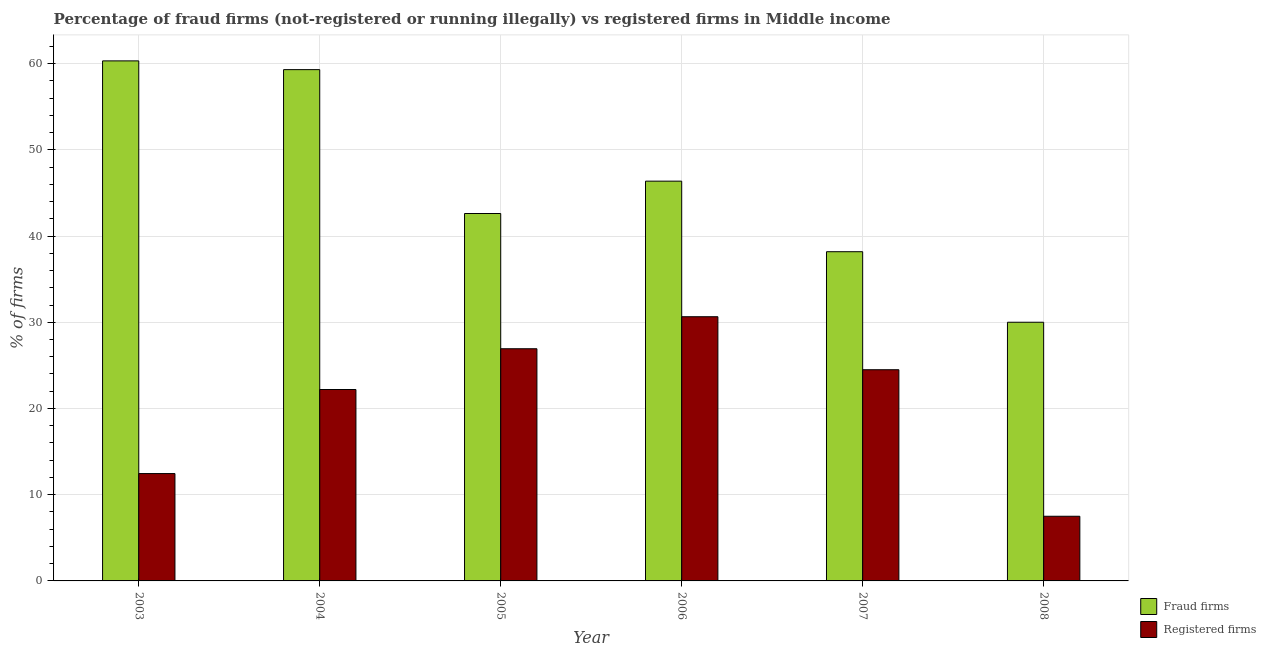How many different coloured bars are there?
Keep it short and to the point. 2. How many bars are there on the 1st tick from the right?
Give a very brief answer. 2. In how many cases, is the number of bars for a given year not equal to the number of legend labels?
Offer a very short reply. 0. What is the percentage of registered firms in 2003?
Ensure brevity in your answer.  12.45. Across all years, what is the maximum percentage of registered firms?
Keep it short and to the point. 30.64. In which year was the percentage of registered firms maximum?
Provide a succinct answer. 2006. What is the total percentage of registered firms in the graph?
Offer a terse response. 124.21. What is the difference between the percentage of fraud firms in 2004 and that in 2007?
Your response must be concise. 21.12. What is the difference between the percentage of fraud firms in 2008 and the percentage of registered firms in 2004?
Make the answer very short. -29.3. What is the average percentage of fraud firms per year?
Ensure brevity in your answer.  46.13. What is the ratio of the percentage of fraud firms in 2004 to that in 2005?
Your answer should be very brief. 1.39. Is the percentage of fraud firms in 2003 less than that in 2005?
Ensure brevity in your answer.  No. Is the difference between the percentage of fraud firms in 2006 and 2008 greater than the difference between the percentage of registered firms in 2006 and 2008?
Your answer should be compact. No. What is the difference between the highest and the second highest percentage of registered firms?
Your answer should be very brief. 3.71. What is the difference between the highest and the lowest percentage of fraud firms?
Your answer should be compact. 30.31. Is the sum of the percentage of registered firms in 2003 and 2008 greater than the maximum percentage of fraud firms across all years?
Keep it short and to the point. No. What does the 2nd bar from the left in 2008 represents?
Provide a succinct answer. Registered firms. What does the 1st bar from the right in 2005 represents?
Make the answer very short. Registered firms. How many years are there in the graph?
Keep it short and to the point. 6. What is the difference between two consecutive major ticks on the Y-axis?
Make the answer very short. 10. Are the values on the major ticks of Y-axis written in scientific E-notation?
Keep it short and to the point. No. Does the graph contain any zero values?
Your answer should be very brief. No. Where does the legend appear in the graph?
Your answer should be very brief. Bottom right. How are the legend labels stacked?
Offer a terse response. Vertical. What is the title of the graph?
Provide a short and direct response. Percentage of fraud firms (not-registered or running illegally) vs registered firms in Middle income. Does "US$" appear as one of the legend labels in the graph?
Make the answer very short. No. What is the label or title of the X-axis?
Provide a succinct answer. Year. What is the label or title of the Y-axis?
Offer a very short reply. % of firms. What is the % of firms in Fraud firms in 2003?
Offer a very short reply. 60.31. What is the % of firms of Registered firms in 2003?
Give a very brief answer. 12.45. What is the % of firms in Fraud firms in 2004?
Offer a very short reply. 59.3. What is the % of firms in Fraud firms in 2005?
Keep it short and to the point. 42.61. What is the % of firms in Registered firms in 2005?
Keep it short and to the point. 26.93. What is the % of firms in Fraud firms in 2006?
Your answer should be compact. 46.36. What is the % of firms in Registered firms in 2006?
Offer a terse response. 30.64. What is the % of firms in Fraud firms in 2007?
Your answer should be very brief. 38.18. What is the % of firms of Registered firms in 2007?
Your response must be concise. 24.49. What is the % of firms in Fraud firms in 2008?
Provide a short and direct response. 30. What is the % of firms of Registered firms in 2008?
Offer a very short reply. 7.5. Across all years, what is the maximum % of firms of Fraud firms?
Keep it short and to the point. 60.31. Across all years, what is the maximum % of firms in Registered firms?
Your answer should be compact. 30.64. Across all years, what is the minimum % of firms in Fraud firms?
Your answer should be very brief. 30. Across all years, what is the minimum % of firms of Registered firms?
Offer a terse response. 7.5. What is the total % of firms in Fraud firms in the graph?
Ensure brevity in your answer.  276.76. What is the total % of firms in Registered firms in the graph?
Your response must be concise. 124.21. What is the difference between the % of firms in Fraud firms in 2003 and that in 2004?
Make the answer very short. 1.02. What is the difference between the % of firms in Registered firms in 2003 and that in 2004?
Provide a succinct answer. -9.75. What is the difference between the % of firms in Fraud firms in 2003 and that in 2005?
Make the answer very short. 17.7. What is the difference between the % of firms in Registered firms in 2003 and that in 2005?
Your answer should be compact. -14.48. What is the difference between the % of firms in Fraud firms in 2003 and that in 2006?
Your answer should be compact. 13.95. What is the difference between the % of firms in Registered firms in 2003 and that in 2006?
Make the answer very short. -18.19. What is the difference between the % of firms in Fraud firms in 2003 and that in 2007?
Give a very brief answer. 22.13. What is the difference between the % of firms in Registered firms in 2003 and that in 2007?
Offer a terse response. -12.04. What is the difference between the % of firms in Fraud firms in 2003 and that in 2008?
Your response must be concise. 30.31. What is the difference between the % of firms in Registered firms in 2003 and that in 2008?
Offer a terse response. 4.95. What is the difference between the % of firms in Fraud firms in 2004 and that in 2005?
Ensure brevity in your answer.  16.69. What is the difference between the % of firms in Registered firms in 2004 and that in 2005?
Give a very brief answer. -4.73. What is the difference between the % of firms in Fraud firms in 2004 and that in 2006?
Ensure brevity in your answer.  12.93. What is the difference between the % of firms of Registered firms in 2004 and that in 2006?
Keep it short and to the point. -8.44. What is the difference between the % of firms of Fraud firms in 2004 and that in 2007?
Your response must be concise. 21.12. What is the difference between the % of firms of Registered firms in 2004 and that in 2007?
Your response must be concise. -2.29. What is the difference between the % of firms in Fraud firms in 2004 and that in 2008?
Ensure brevity in your answer.  29.3. What is the difference between the % of firms in Fraud firms in 2005 and that in 2006?
Your response must be concise. -3.75. What is the difference between the % of firms in Registered firms in 2005 and that in 2006?
Your answer should be compact. -3.71. What is the difference between the % of firms in Fraud firms in 2005 and that in 2007?
Ensure brevity in your answer.  4.43. What is the difference between the % of firms of Registered firms in 2005 and that in 2007?
Your answer should be very brief. 2.43. What is the difference between the % of firms of Fraud firms in 2005 and that in 2008?
Make the answer very short. 12.61. What is the difference between the % of firms of Registered firms in 2005 and that in 2008?
Your response must be concise. 19.43. What is the difference between the % of firms in Fraud firms in 2006 and that in 2007?
Give a very brief answer. 8.18. What is the difference between the % of firms of Registered firms in 2006 and that in 2007?
Your answer should be compact. 6.15. What is the difference between the % of firms in Fraud firms in 2006 and that in 2008?
Keep it short and to the point. 16.36. What is the difference between the % of firms of Registered firms in 2006 and that in 2008?
Your response must be concise. 23.14. What is the difference between the % of firms in Fraud firms in 2007 and that in 2008?
Your response must be concise. 8.18. What is the difference between the % of firms in Registered firms in 2007 and that in 2008?
Provide a short and direct response. 16.99. What is the difference between the % of firms in Fraud firms in 2003 and the % of firms in Registered firms in 2004?
Provide a short and direct response. 38.11. What is the difference between the % of firms of Fraud firms in 2003 and the % of firms of Registered firms in 2005?
Your answer should be compact. 33.38. What is the difference between the % of firms in Fraud firms in 2003 and the % of firms in Registered firms in 2006?
Your response must be concise. 29.67. What is the difference between the % of firms of Fraud firms in 2003 and the % of firms of Registered firms in 2007?
Give a very brief answer. 35.82. What is the difference between the % of firms in Fraud firms in 2003 and the % of firms in Registered firms in 2008?
Your answer should be very brief. 52.81. What is the difference between the % of firms in Fraud firms in 2004 and the % of firms in Registered firms in 2005?
Your answer should be compact. 32.37. What is the difference between the % of firms of Fraud firms in 2004 and the % of firms of Registered firms in 2006?
Ensure brevity in your answer.  28.66. What is the difference between the % of firms of Fraud firms in 2004 and the % of firms of Registered firms in 2007?
Your answer should be compact. 34.8. What is the difference between the % of firms in Fraud firms in 2004 and the % of firms in Registered firms in 2008?
Your answer should be very brief. 51.8. What is the difference between the % of firms in Fraud firms in 2005 and the % of firms in Registered firms in 2006?
Provide a short and direct response. 11.97. What is the difference between the % of firms of Fraud firms in 2005 and the % of firms of Registered firms in 2007?
Make the answer very short. 18.12. What is the difference between the % of firms in Fraud firms in 2005 and the % of firms in Registered firms in 2008?
Your answer should be compact. 35.11. What is the difference between the % of firms of Fraud firms in 2006 and the % of firms of Registered firms in 2007?
Your response must be concise. 21.87. What is the difference between the % of firms of Fraud firms in 2006 and the % of firms of Registered firms in 2008?
Keep it short and to the point. 38.86. What is the difference between the % of firms in Fraud firms in 2007 and the % of firms in Registered firms in 2008?
Offer a very short reply. 30.68. What is the average % of firms of Fraud firms per year?
Offer a very short reply. 46.13. What is the average % of firms of Registered firms per year?
Keep it short and to the point. 20.7. In the year 2003, what is the difference between the % of firms in Fraud firms and % of firms in Registered firms?
Provide a short and direct response. 47.86. In the year 2004, what is the difference between the % of firms in Fraud firms and % of firms in Registered firms?
Your answer should be very brief. 37.1. In the year 2005, what is the difference between the % of firms of Fraud firms and % of firms of Registered firms?
Give a very brief answer. 15.68. In the year 2006, what is the difference between the % of firms of Fraud firms and % of firms of Registered firms?
Your answer should be compact. 15.72. In the year 2007, what is the difference between the % of firms in Fraud firms and % of firms in Registered firms?
Provide a short and direct response. 13.69. What is the ratio of the % of firms in Fraud firms in 2003 to that in 2004?
Your response must be concise. 1.02. What is the ratio of the % of firms in Registered firms in 2003 to that in 2004?
Give a very brief answer. 0.56. What is the ratio of the % of firms of Fraud firms in 2003 to that in 2005?
Offer a terse response. 1.42. What is the ratio of the % of firms in Registered firms in 2003 to that in 2005?
Offer a terse response. 0.46. What is the ratio of the % of firms in Fraud firms in 2003 to that in 2006?
Make the answer very short. 1.3. What is the ratio of the % of firms of Registered firms in 2003 to that in 2006?
Your answer should be very brief. 0.41. What is the ratio of the % of firms in Fraud firms in 2003 to that in 2007?
Offer a very short reply. 1.58. What is the ratio of the % of firms in Registered firms in 2003 to that in 2007?
Your answer should be compact. 0.51. What is the ratio of the % of firms in Fraud firms in 2003 to that in 2008?
Your answer should be compact. 2.01. What is the ratio of the % of firms in Registered firms in 2003 to that in 2008?
Offer a terse response. 1.66. What is the ratio of the % of firms of Fraud firms in 2004 to that in 2005?
Provide a succinct answer. 1.39. What is the ratio of the % of firms in Registered firms in 2004 to that in 2005?
Provide a succinct answer. 0.82. What is the ratio of the % of firms in Fraud firms in 2004 to that in 2006?
Ensure brevity in your answer.  1.28. What is the ratio of the % of firms in Registered firms in 2004 to that in 2006?
Provide a succinct answer. 0.72. What is the ratio of the % of firms in Fraud firms in 2004 to that in 2007?
Make the answer very short. 1.55. What is the ratio of the % of firms of Registered firms in 2004 to that in 2007?
Keep it short and to the point. 0.91. What is the ratio of the % of firms in Fraud firms in 2004 to that in 2008?
Provide a succinct answer. 1.98. What is the ratio of the % of firms of Registered firms in 2004 to that in 2008?
Offer a terse response. 2.96. What is the ratio of the % of firms in Fraud firms in 2005 to that in 2006?
Offer a terse response. 0.92. What is the ratio of the % of firms in Registered firms in 2005 to that in 2006?
Give a very brief answer. 0.88. What is the ratio of the % of firms in Fraud firms in 2005 to that in 2007?
Ensure brevity in your answer.  1.12. What is the ratio of the % of firms of Registered firms in 2005 to that in 2007?
Your answer should be very brief. 1.1. What is the ratio of the % of firms in Fraud firms in 2005 to that in 2008?
Ensure brevity in your answer.  1.42. What is the ratio of the % of firms of Registered firms in 2005 to that in 2008?
Give a very brief answer. 3.59. What is the ratio of the % of firms of Fraud firms in 2006 to that in 2007?
Your answer should be compact. 1.21. What is the ratio of the % of firms of Registered firms in 2006 to that in 2007?
Offer a terse response. 1.25. What is the ratio of the % of firms of Fraud firms in 2006 to that in 2008?
Your answer should be compact. 1.55. What is the ratio of the % of firms of Registered firms in 2006 to that in 2008?
Make the answer very short. 4.09. What is the ratio of the % of firms in Fraud firms in 2007 to that in 2008?
Offer a terse response. 1.27. What is the ratio of the % of firms of Registered firms in 2007 to that in 2008?
Make the answer very short. 3.27. What is the difference between the highest and the second highest % of firms of Fraud firms?
Keep it short and to the point. 1.02. What is the difference between the highest and the second highest % of firms of Registered firms?
Your answer should be compact. 3.71. What is the difference between the highest and the lowest % of firms in Fraud firms?
Offer a terse response. 30.31. What is the difference between the highest and the lowest % of firms of Registered firms?
Make the answer very short. 23.14. 